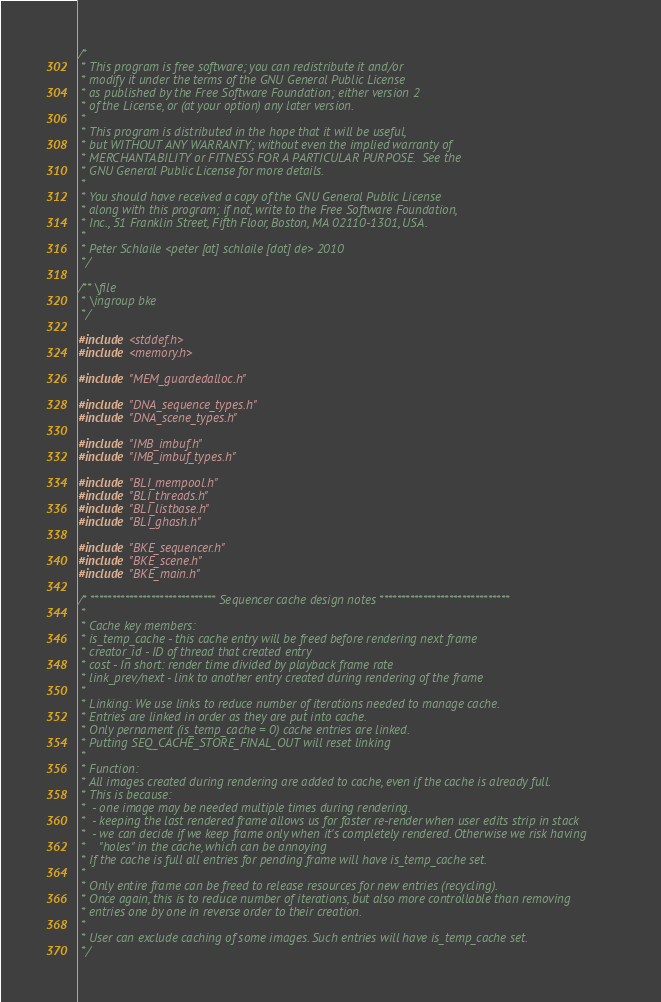Convert code to text. <code><loc_0><loc_0><loc_500><loc_500><_C_>/*
 * This program is free software; you can redistribute it and/or
 * modify it under the terms of the GNU General Public License
 * as published by the Free Software Foundation; either version 2
 * of the License, or (at your option) any later version.
 *
 * This program is distributed in the hope that it will be useful,
 * but WITHOUT ANY WARRANTY; without even the implied warranty of
 * MERCHANTABILITY or FITNESS FOR A PARTICULAR PURPOSE.  See the
 * GNU General Public License for more details.
 *
 * You should have received a copy of the GNU General Public License
 * along with this program; if not, write to the Free Software Foundation,
 * Inc., 51 Franklin Street, Fifth Floor, Boston, MA 02110-1301, USA.
 *
 * Peter Schlaile <peter [at] schlaile [dot] de> 2010
 */

/** \file
 * \ingroup bke
 */

#include <stddef.h>
#include <memory.h>

#include "MEM_guardedalloc.h"

#include "DNA_sequence_types.h"
#include "DNA_scene_types.h"

#include "IMB_imbuf.h"
#include "IMB_imbuf_types.h"

#include "BLI_mempool.h"
#include "BLI_threads.h"
#include "BLI_listbase.h"
#include "BLI_ghash.h"

#include "BKE_sequencer.h"
#include "BKE_scene.h"
#include "BKE_main.h"

/* ***************************** Sequencer cache design notes ******************************
 *
 * Cache key members:
 * is_temp_cache - this cache entry will be freed before rendering next frame
 * creator_id - ID of thread that created entry
 * cost - In short: render time divided by playback frame rate
 * link_prev/next - link to another entry created during rendering of the frame
 *
 * Linking: We use links to reduce number of iterations needed to manage cache.
 * Entries are linked in order as they are put into cache.
 * Only pernament (is_temp_cache = 0) cache entries are linked.
 * Putting SEQ_CACHE_STORE_FINAL_OUT will reset linking
 *
 * Function:
 * All images created during rendering are added to cache, even if the cache is already full.
 * This is because:
 *  - one image may be needed multiple times during rendering.
 *  - keeping the last rendered frame allows us for faster re-render when user edits strip in stack
 *  - we can decide if we keep frame only when it's completely rendered. Otherwise we risk having
 *    "holes" in the cache, which can be annoying
 * If the cache is full all entries for pending frame will have is_temp_cache set.
 *
 * Only entire frame can be freed to release resources for new entries (recycling).
 * Once again, this is to reduce number of iterations, but also more controllable than removing
 * entries one by one in reverse order to their creation.
 *
 * User can exclude caching of some images. Such entries will have is_temp_cache set.
 */
</code> 